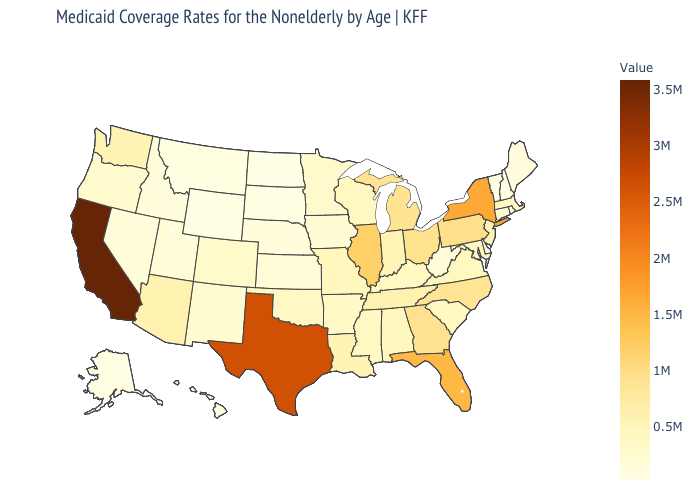Does Texas have a higher value than California?
Short answer required. No. Is the legend a continuous bar?
Concise answer only. Yes. Which states have the lowest value in the Northeast?
Write a very short answer. Vermont. Among the states that border California , does Oregon have the highest value?
Write a very short answer. No. Among the states that border West Virginia , which have the lowest value?
Short answer required. Kentucky. Does Connecticut have the highest value in the Northeast?
Write a very short answer. No. 